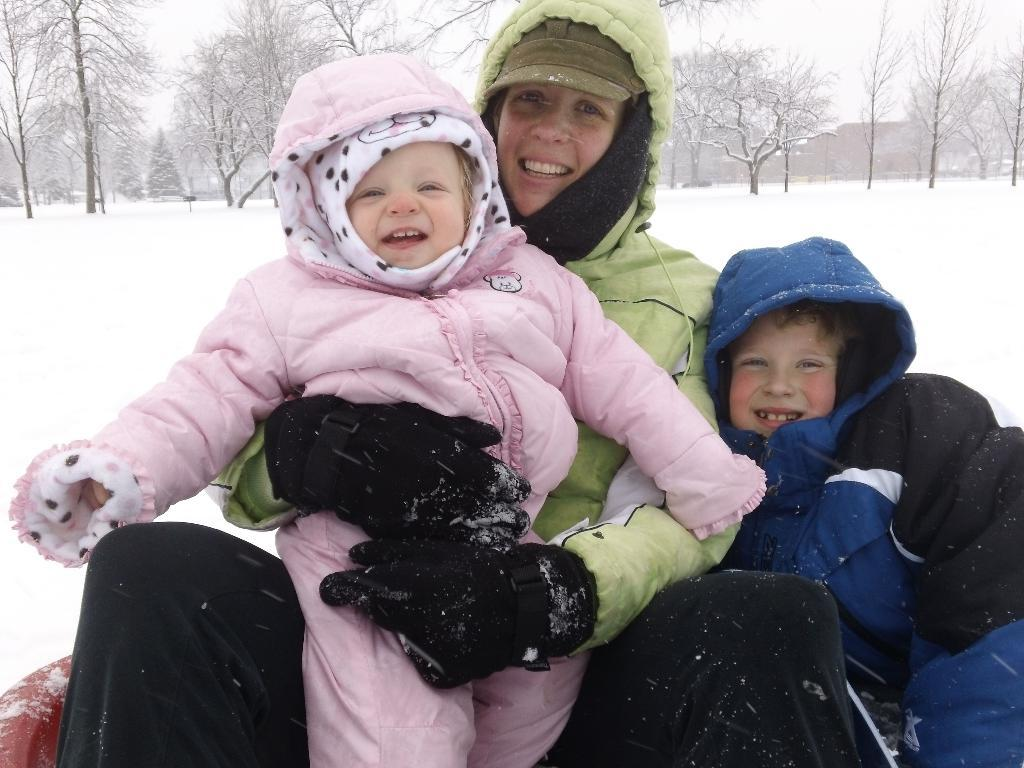How many people are in the image? There are three people in the image. What is the facial expression of the people in the image? The people are smiling. What type of weather is depicted in the image? There is snow in the image. What type of vegetation can be seen in the image? There are trees in the image. What can be seen in the background of the image? There are buildings in the background of the image. What type of plane can be seen flying over the people in the image? There is no plane visible in the image; it only features three people, snow, trees, and buildings in the background. What type of army is present in the image? There is no army present in the image; it only features three people, snow, trees, and buildings in the background. 